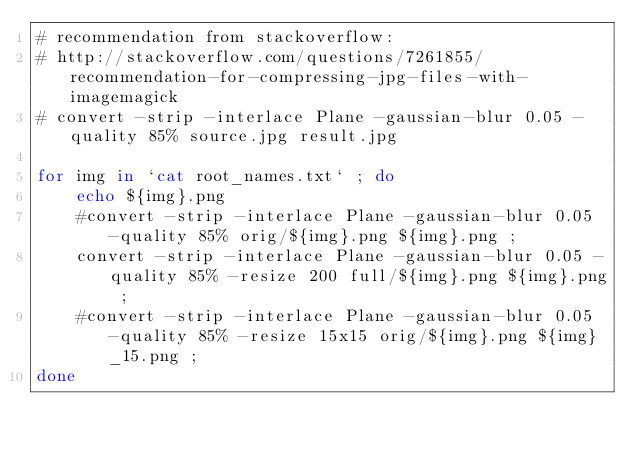<code> <loc_0><loc_0><loc_500><loc_500><_Bash_># recommendation from stackoverflow:
# http://stackoverflow.com/questions/7261855/recommendation-for-compressing-jpg-files-with-imagemagick
# convert -strip -interlace Plane -gaussian-blur 0.05 -quality 85% source.jpg result.jpg

for img in `cat root_names.txt` ; do
    echo ${img}.png
    #convert -strip -interlace Plane -gaussian-blur 0.05 -quality 85% orig/${img}.png ${img}.png ;
    convert -strip -interlace Plane -gaussian-blur 0.05 -quality 85% -resize 200 full/${img}.png ${img}.png ;
    #convert -strip -interlace Plane -gaussian-blur 0.05 -quality 85% -resize 15x15 orig/${img}.png ${img}_15.png ;
done

</code> 